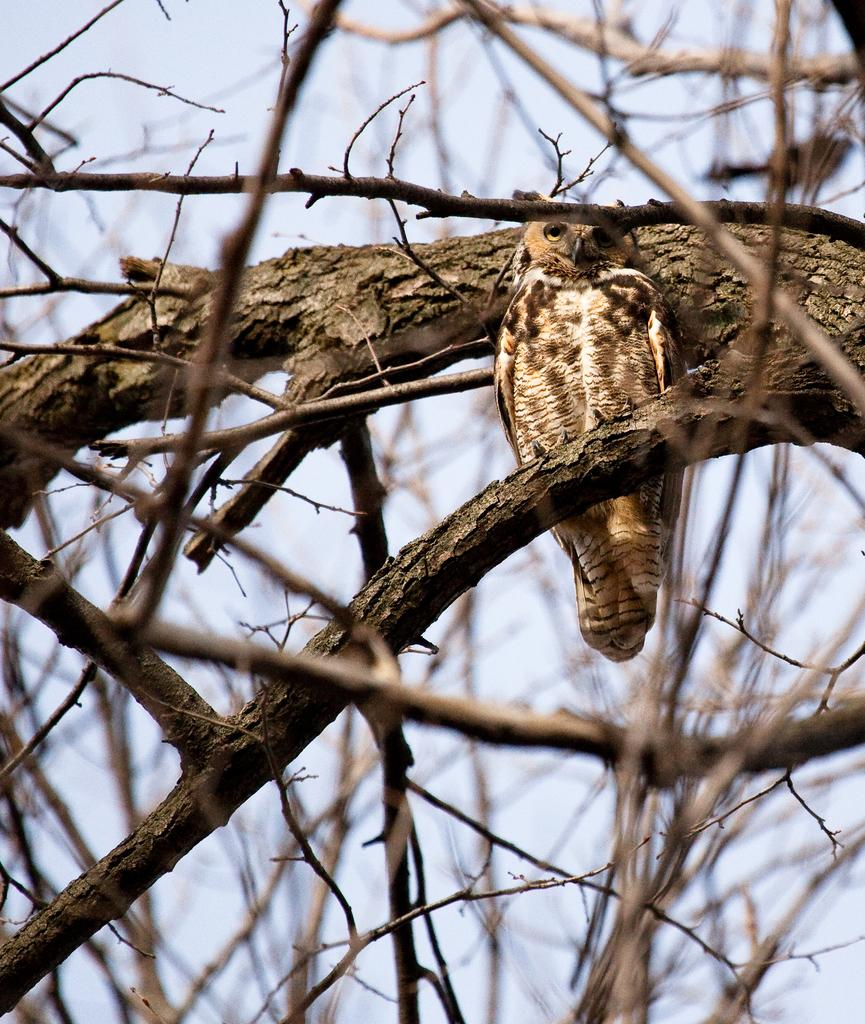What animal is present in the image? There is an owl in the image. Where is the owl located? The owl is sitting on a tree branch. How many branches can be seen in the image? There are three branches visible in the image. What is the color of the sky in the image? The sky is pale blue in the image. What type of trail can be seen in the image? There is no trail present in the image; it features an owl sitting on a tree branch with a pale blue sky. How does the owl use the scissors in the image? There are no scissors present in the image; the owl is simply sitting on a tree branch. 